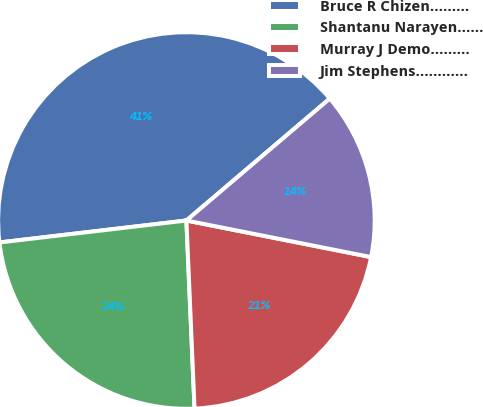<chart> <loc_0><loc_0><loc_500><loc_500><pie_chart><fcel>Bruce R Chizen………<fcel>Shantanu Narayen……<fcel>Murray J Demo………<fcel>Jim Stephens…………<nl><fcel>40.65%<fcel>23.83%<fcel>21.2%<fcel>14.33%<nl></chart> 